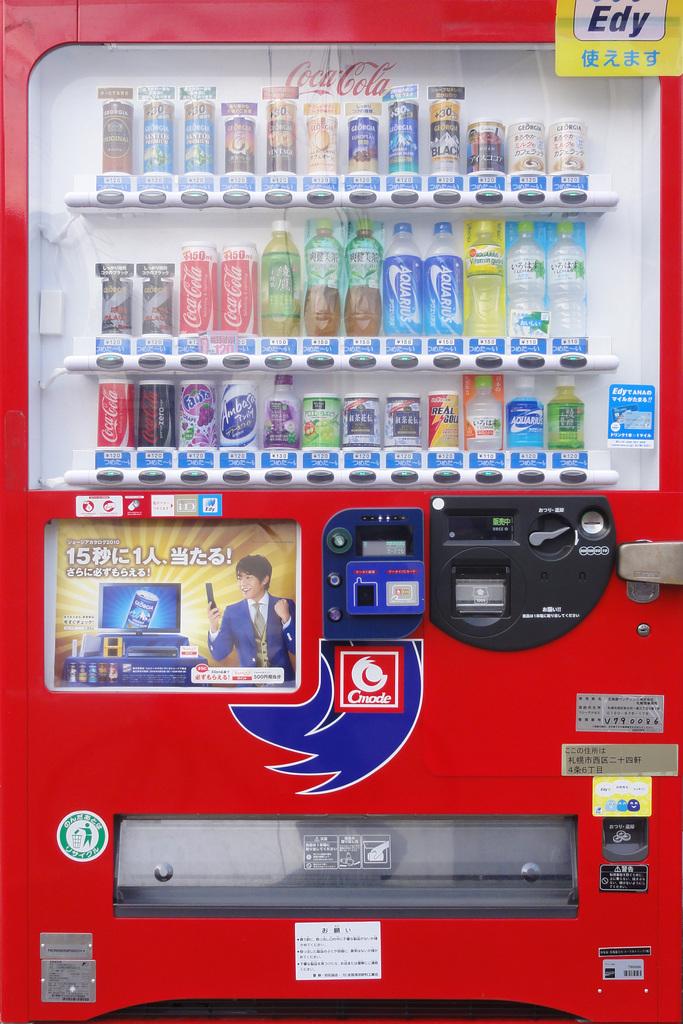What type of vending machine is this?
Provide a short and direct response. Coca cola. 